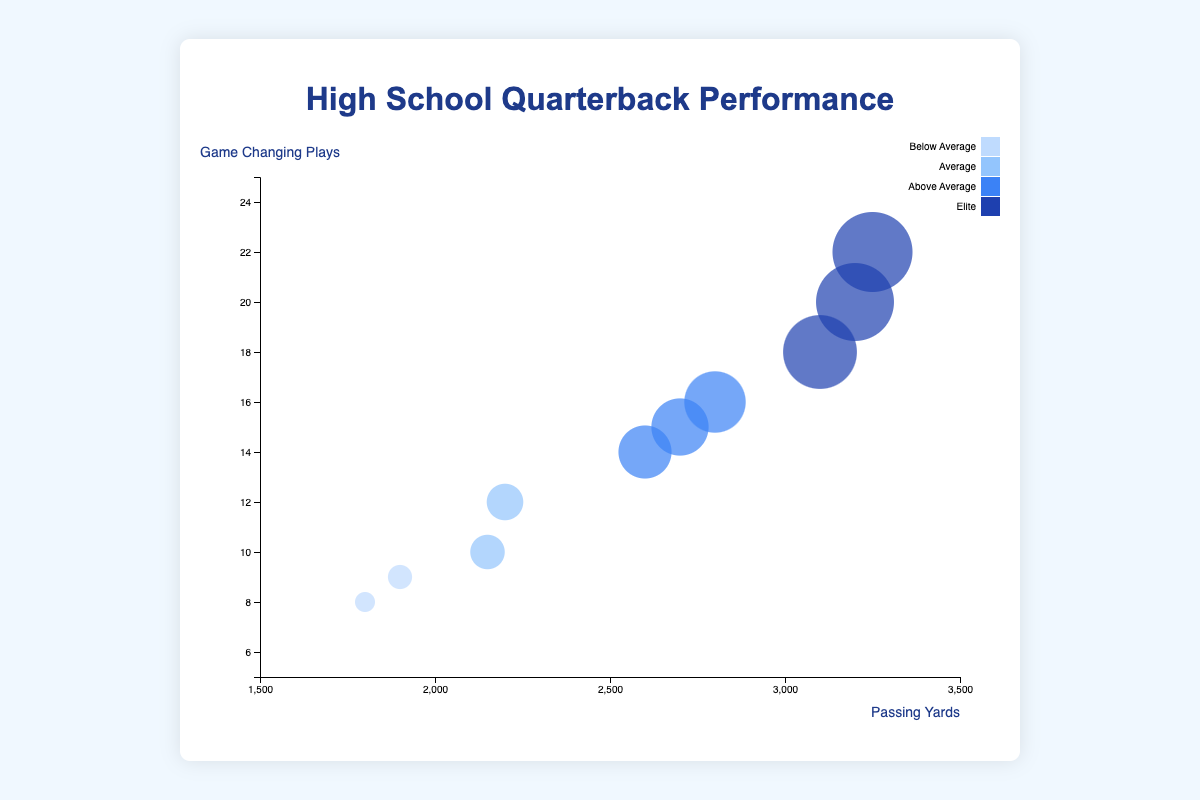What is the title of the chart? The title of the chart provides a brief description of the content presented. Looking at the figure, the title is displayed prominently at the top.
Answer: High School Quarterback Performance How many Elite tier quarterbacks are displayed in the chart? Elite-tier information can be found in the legend and by counting the bubbles colored according to that tier.
Answer: 3 Which player has the highest number of game-changing plays? By observing the y-axis and finding the bubble that reaches the highest point, we identify the player. The tooltip will confirm the player's name and details when hovered over.
Answer: Ethan Wilson Is there a correlation between passing yards and game-changing plays among the quarterbacks? By examining the trend in the positions of the bubbles, we can determine if an increase in passing yards leads to more game-changing plays. Since most bubbles with higher passing yards also have a high number of game-changing plays, there's a positive correlation.
Answer: Yes, a positive correlation Who has more game-changing plays, Alexander Johnson or Brian Mitchell? We compare the y-values (game-changing plays) of the bubbles representing Alexander Johnson and Brian Mitchell by checking their positions on the y-axis.
Answer: Alexander Johnson How do Elite quarterbacks compare to Below Average quarterbacks in terms of passing yards? We compare the passing yard ranges of bubbles colored for each tier, noting that Elite bubbles tend to cluster at higher x-values compared to Below Average bubbles.
Answer: Elite quarterbacks have higher passing yards What is the average passing yards for Above Average tier quarterbacks? We locate the Above Average tier bubbles and sum their passing yard values, then divide the total by the number of Above Average quarterbacks. Their passing yards are 2700, 2800, and 2600, totaling 8100. Dividing this by 3 gives an average.
Answer: 2700 Which quarterback from the Below Average tier has the highest passing yards? We look for the bubbles colored for the Below Average tier and identify which one has the highest x-value (passing yards), confirmed by hovering over the tooltip.
Answer: Isaac Turner What are the typical bubble sizes for Average tier quarterbacks? Bubble sizes represent passing yards. We observe the scale and estimate the size range for bubbles colored for the Average tier. Average tier quarterbacks seem to have moderate-sized bubbles compared to Elite and Below Average.
Answer: Moderate-sized Does Ethan Wilson also lead in passing yards among the Elite tier? By comparing the x-values (passing yards) of Elite quarterbacks, specifically finding Ethan Wilson’s position, we see he has the highest value compared to other Elite examples like Alexander Johnson and Brian Mitchell.
Answer: Yes 